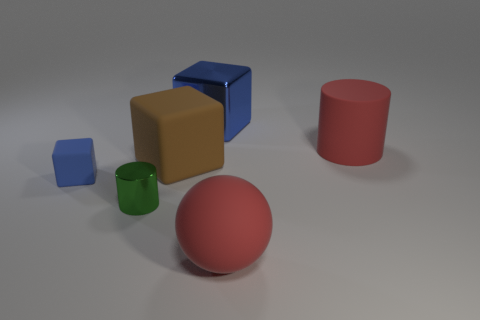There is a tiny object that is behind the small green cylinder; how many things are in front of it?
Offer a very short reply. 2. Do the small shiny object and the big blue thing have the same shape?
Provide a succinct answer. No. There is a red rubber thing that is the same shape as the green shiny object; what size is it?
Give a very brief answer. Large. There is a large thing behind the large red thing that is behind the green metallic cylinder; what shape is it?
Your answer should be compact. Cube. How big is the red cylinder?
Give a very brief answer. Large. The big brown rubber thing is what shape?
Provide a succinct answer. Cube. Is the shape of the large blue metal thing the same as the metal thing in front of the tiny rubber thing?
Make the answer very short. No. There is a metal thing in front of the large blue shiny block; is it the same shape as the big brown thing?
Keep it short and to the point. No. What number of things are in front of the brown cube and on the right side of the large brown rubber thing?
Your answer should be very brief. 1. How many other things are the same size as the rubber ball?
Offer a terse response. 3. 